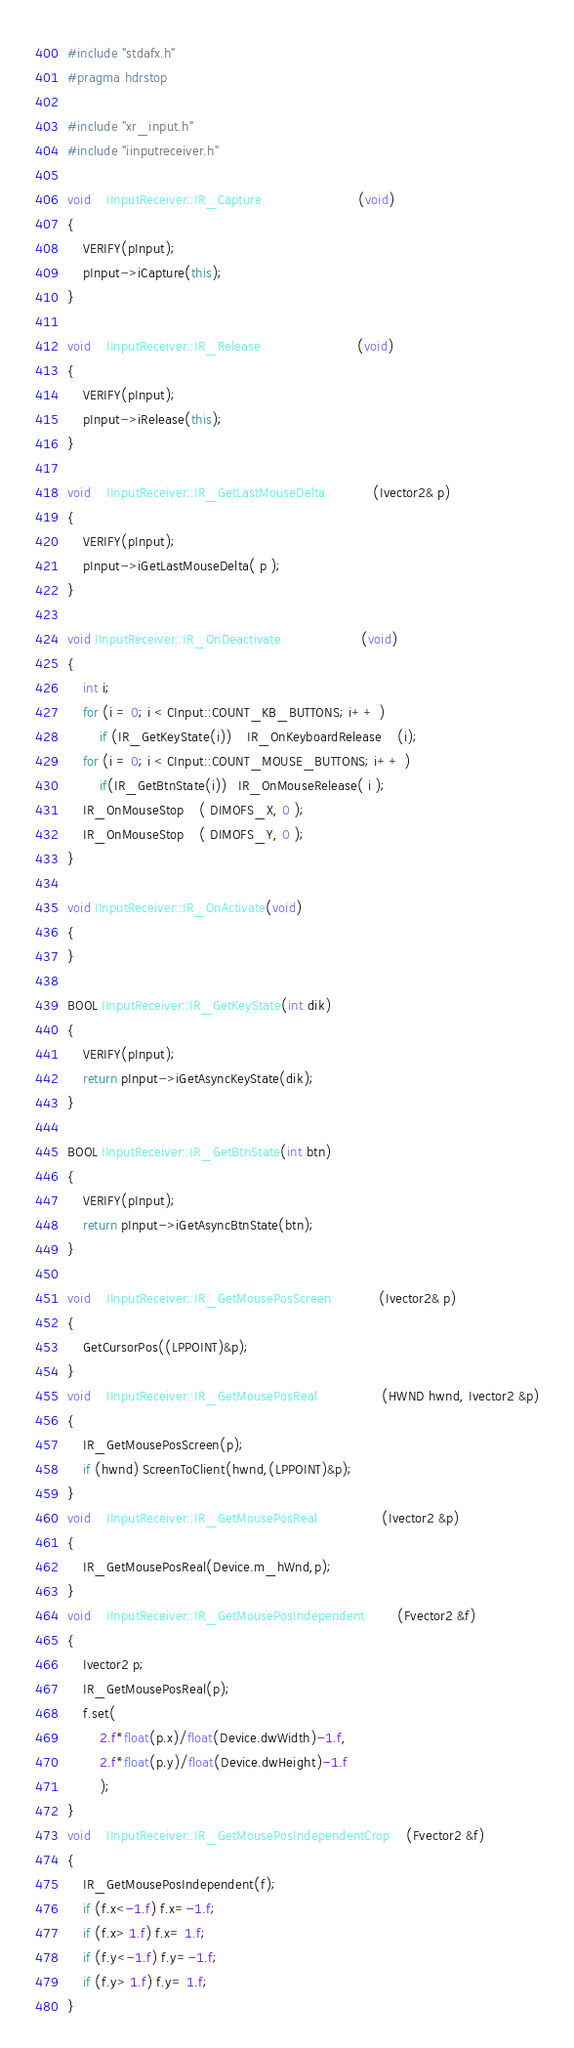<code> <loc_0><loc_0><loc_500><loc_500><_C++_>#include "stdafx.h"
#pragma hdrstop

#include "xr_input.h"
#include "iinputreceiver.h"

void	IInputReceiver::IR_Capture						(void)
{
	VERIFY(pInput);
	pInput->iCapture(this);
}

void	IInputReceiver::IR_Release						(void)
{
	VERIFY(pInput);
	pInput->iRelease(this);
}

void	IInputReceiver::IR_GetLastMouseDelta			(Ivector2& p)
{
	VERIFY(pInput);
	pInput->iGetLastMouseDelta( p );
}

void IInputReceiver::IR_OnDeactivate					(void)
{
	int i;
	for (i = 0; i < CInput::COUNT_KB_BUTTONS; i++ )
		if (IR_GetKeyState(i))	IR_OnKeyboardRelease	(i);
	for (i = 0; i < CInput::COUNT_MOUSE_BUTTONS; i++ )
		if(IR_GetBtnState(i))   IR_OnMouseRelease( i );
	IR_OnMouseStop	( DIMOFS_X, 0 );
	IR_OnMouseStop	( DIMOFS_Y, 0 );
}

void IInputReceiver::IR_OnActivate(void)
{
}

BOOL IInputReceiver::IR_GetKeyState(int dik)
{
	VERIFY(pInput);
	return pInput->iGetAsyncKeyState(dik);
}

BOOL IInputReceiver::IR_GetBtnState(int btn)
{
	VERIFY(pInput);
	return pInput->iGetAsyncBtnState(btn);
}

void	IInputReceiver::IR_GetMousePosScreen			(Ivector2& p)
{
	GetCursorPos((LPPOINT)&p);
}
void	IInputReceiver::IR_GetMousePosReal				(HWND hwnd, Ivector2 &p)
{
	IR_GetMousePosScreen(p);
	if (hwnd) ScreenToClient(hwnd,(LPPOINT)&p);
}
void	IInputReceiver::IR_GetMousePosReal				(Ivector2 &p)
{
	IR_GetMousePosReal(Device.m_hWnd,p);
}
void	IInputReceiver::IR_GetMousePosIndependent		(Fvector2 &f)
{
	Ivector2 p;
	IR_GetMousePosReal(p);
	f.set(
		2.f*float(p.x)/float(Device.dwWidth)-1.f,
		2.f*float(p.y)/float(Device.dwHeight)-1.f
		);
}
void	IInputReceiver::IR_GetMousePosIndependentCrop	(Fvector2 &f)
{
	IR_GetMousePosIndependent(f);
	if (f.x<-1.f) f.x=-1.f;
	if (f.x> 1.f) f.x= 1.f;
	if (f.y<-1.f) f.y=-1.f;
	if (f.y> 1.f) f.y= 1.f;
}
</code> 